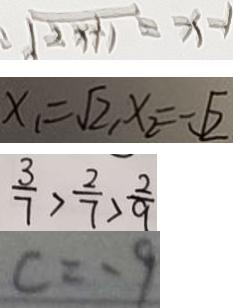Convert formula to latex. <formula><loc_0><loc_0><loc_500><loc_500>\sqrt { 2 x + 1 } = x - 1 
 x _ { 1 } = \sqrt { 2 } , x _ { 2 } = \sqrt { 2 } 
 \frac { 3 } { 7 } > \frac { 2 } { 7 } > \frac { 2 } { 9 } 
 c = - 9</formula> 